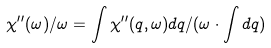Convert formula to latex. <formula><loc_0><loc_0><loc_500><loc_500>\chi ^ { \prime \prime } ( \omega ) / \omega = \int \chi ^ { \prime \prime } ( q , \omega ) d q / ( \omega \cdot \int d q )</formula> 